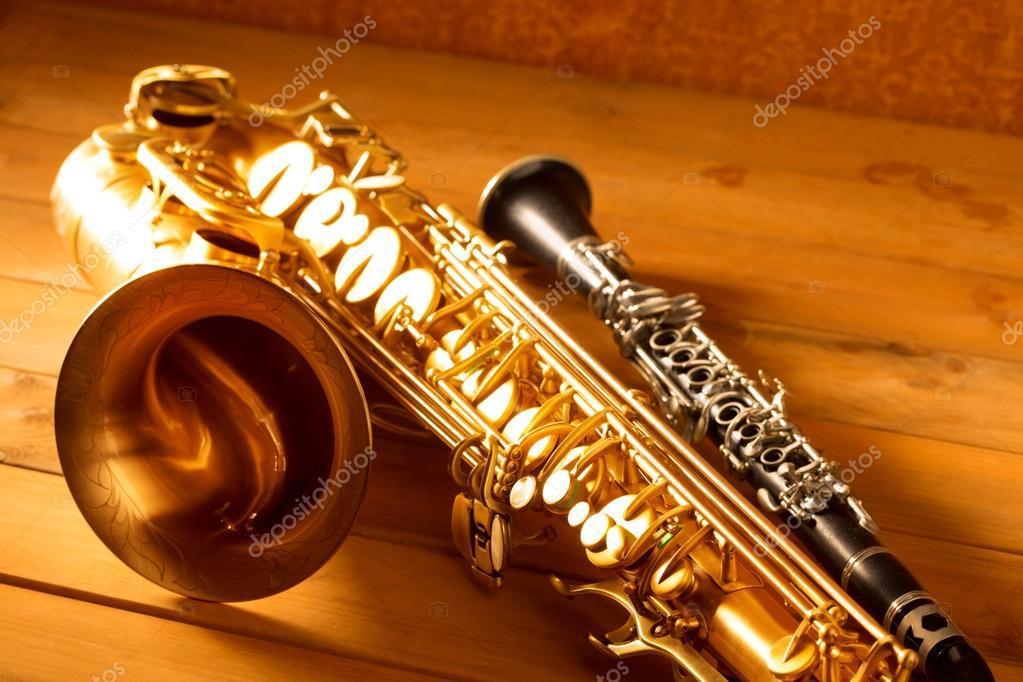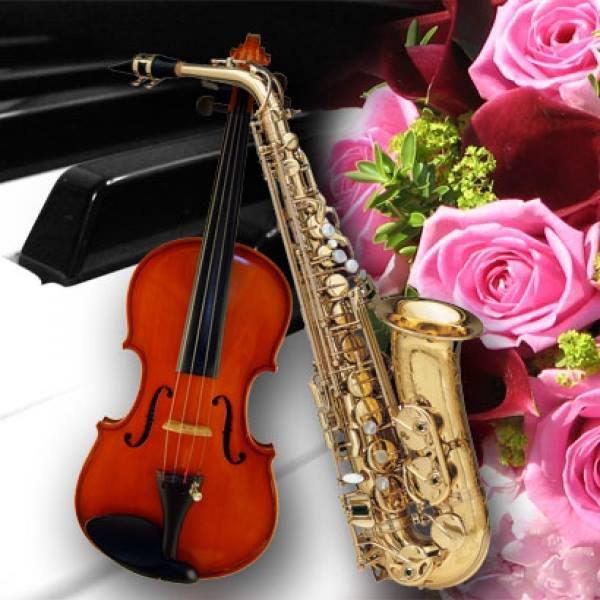The first image is the image on the left, the second image is the image on the right. Examine the images to the left and right. Is the description "Both images contain three instruments." accurate? Answer yes or no. No. The first image is the image on the left, the second image is the image on the right. For the images displayed, is the sentence "A violin is next to a saxophone in each image." factually correct? Answer yes or no. No. 